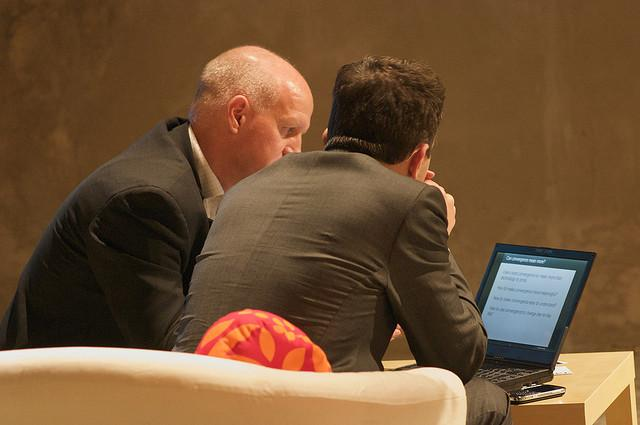What type of battery is best for laptop? Please explain your reasoning. nimh. The best battery is one that is for nimh. 